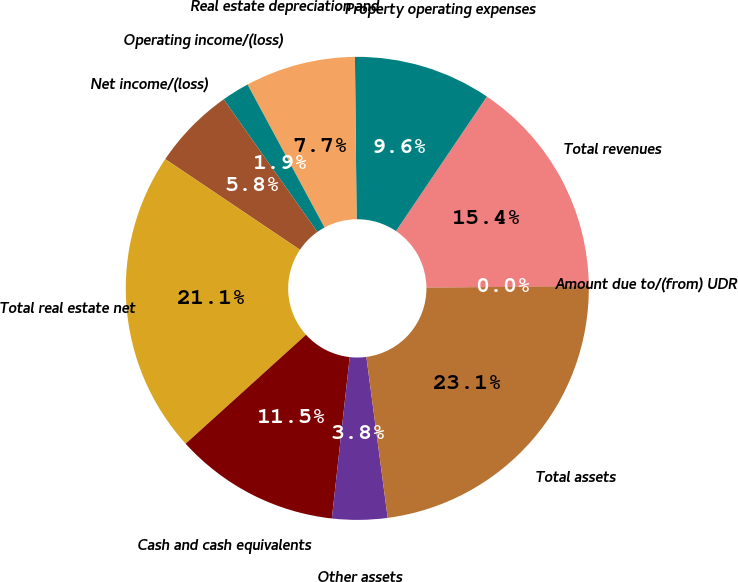Convert chart. <chart><loc_0><loc_0><loc_500><loc_500><pie_chart><fcel>Total revenues<fcel>Property operating expenses<fcel>Real estate depreciation and<fcel>Operating income/(loss)<fcel>Net income/(loss)<fcel>Total real estate net<fcel>Cash and cash equivalents<fcel>Other assets<fcel>Total assets<fcel>Amount due to/(from) UDR<nl><fcel>15.38%<fcel>9.62%<fcel>7.7%<fcel>1.93%<fcel>5.78%<fcel>21.14%<fcel>11.54%<fcel>3.85%<fcel>23.06%<fcel>0.01%<nl></chart> 